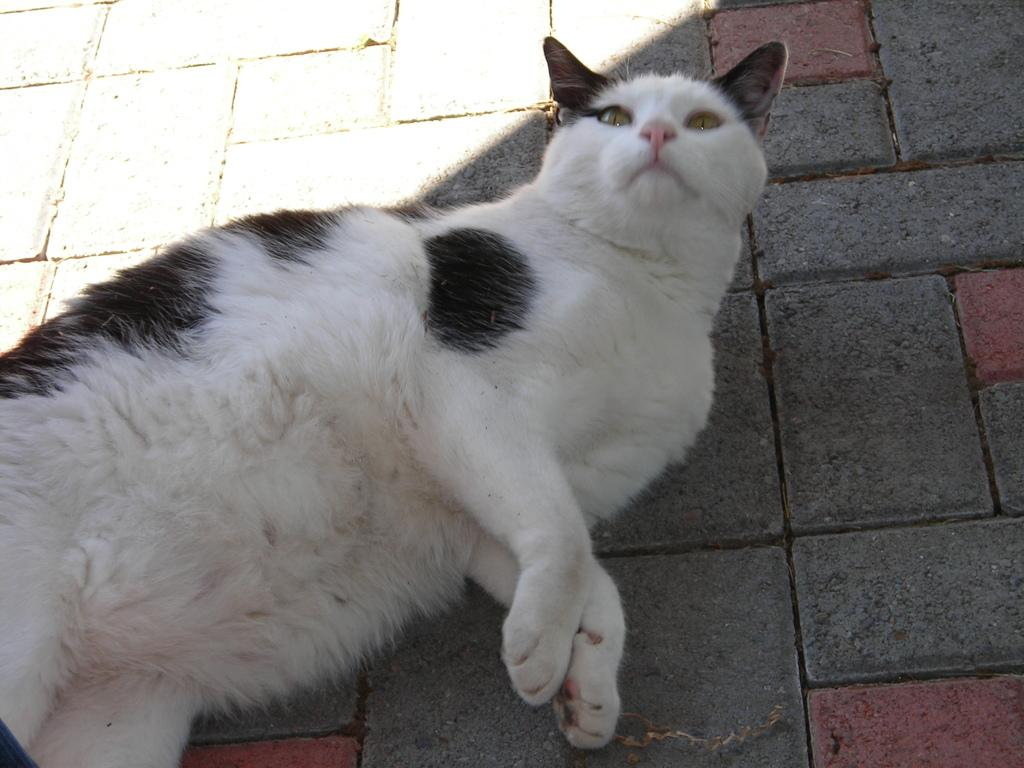What type of animal is present in the image? There is a cat in the image. Where is the cat located in the image? The cat is on the floor. What organization does the cat belong to in the image? There is no indication in the image that the cat belongs to any organization. What is the purpose of the cat in the image? The image does not provide any information about the purpose of the cat. 